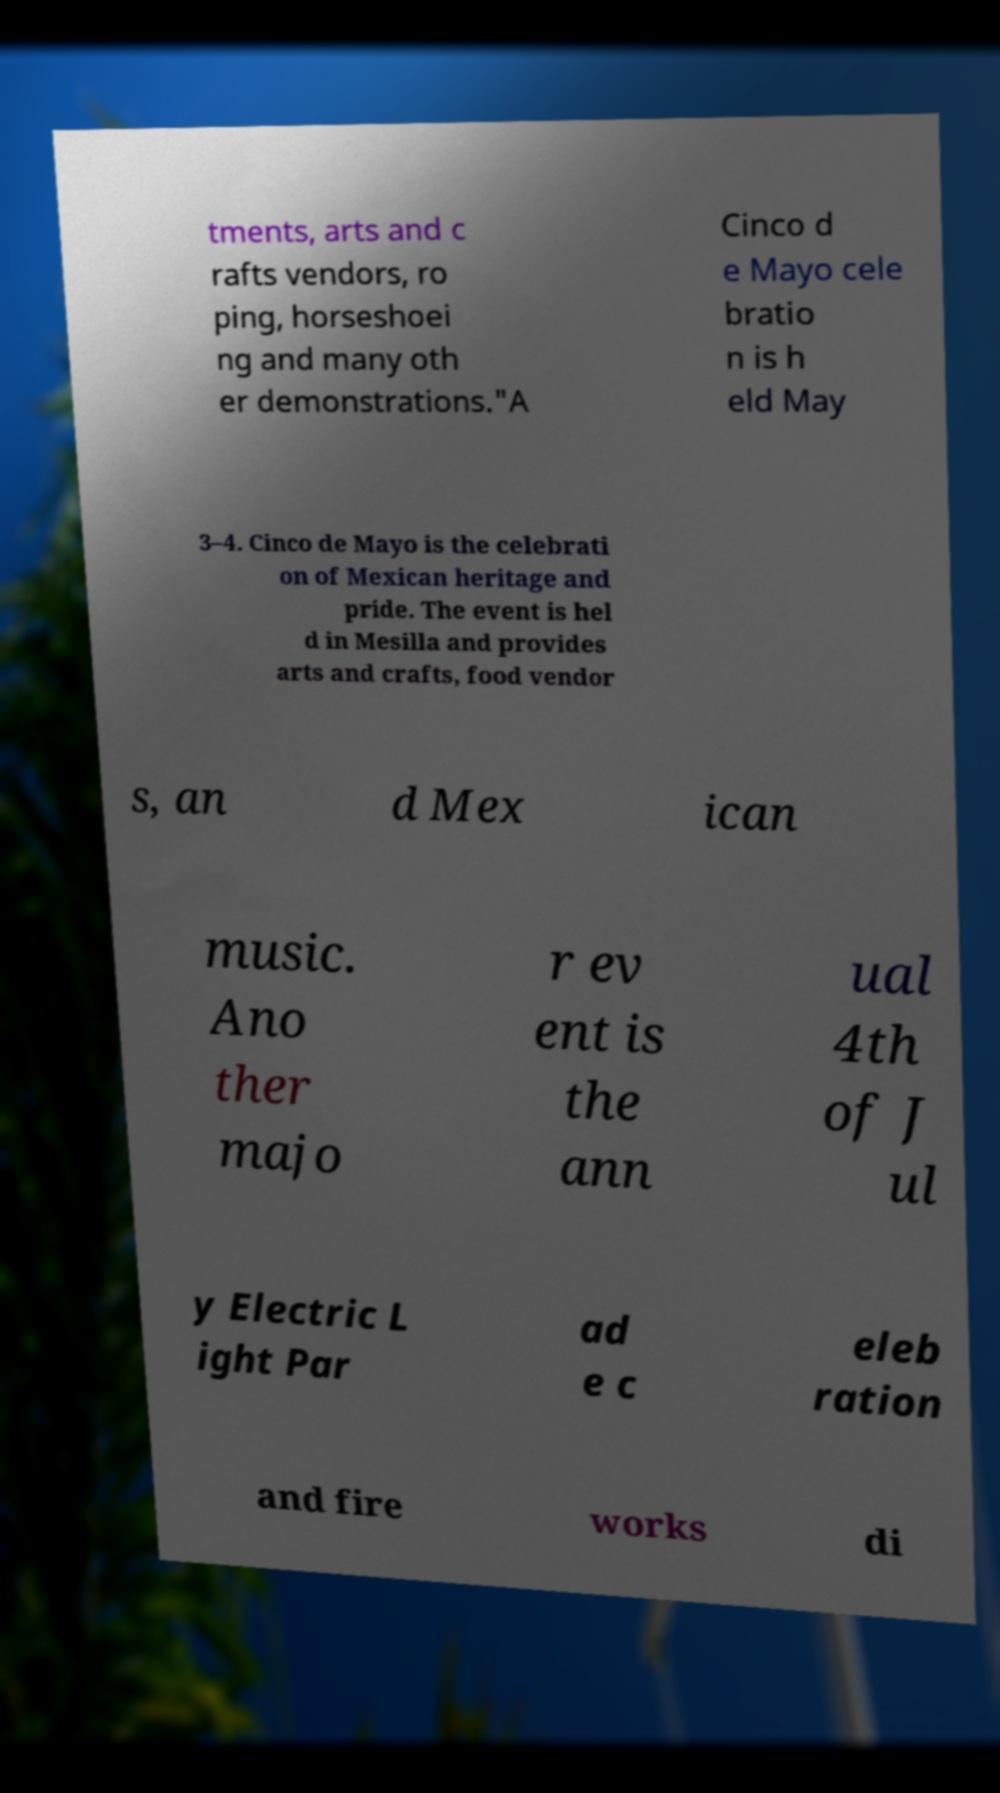Can you accurately transcribe the text from the provided image for me? tments, arts and c rafts vendors, ro ping, horseshoei ng and many oth er demonstrations."A Cinco d e Mayo cele bratio n is h eld May 3–4. Cinco de Mayo is the celebrati on of Mexican heritage and pride. The event is hel d in Mesilla and provides arts and crafts, food vendor s, an d Mex ican music. Ano ther majo r ev ent is the ann ual 4th of J ul y Electric L ight Par ad e c eleb ration and fire works di 